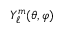Convert formula to latex. <formula><loc_0><loc_0><loc_500><loc_500>Y _ { \ell } ^ { m } ( \theta , \varphi )</formula> 